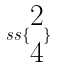Convert formula to latex. <formula><loc_0><loc_0><loc_500><loc_500>s s \{ \begin{matrix} 2 \\ 4 \end{matrix} \}</formula> 